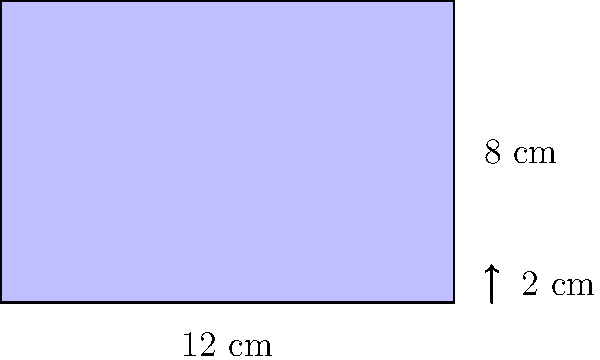You're designing a special cushion to support your baby's flat forehead during tummy time. The cushion is rectangular with dimensions 12 cm by 8 cm and a thickness of 2 cm. Calculate the total surface area of the cushion in square centimeters. To find the total surface area of the rectangular cushion, we need to calculate the area of all six faces and sum them up. Let's break it down step-by-step:

1. Front and back faces (largest faces):
   Area = length × width
   $A_1 = 12 \text{ cm} \times 8 \text{ cm} = 96 \text{ cm}^2$
   There are two of these faces, so: $2 \times 96 \text{ cm}^2 = 192 \text{ cm}^2$

2. Top and bottom faces:
   Area = length × thickness
   $A_2 = 12 \text{ cm} \times 2 \text{ cm} = 24 \text{ cm}^2$
   There are two of these faces, so: $2 \times 24 \text{ cm}^2 = 48 \text{ cm}^2$

3. Side faces:
   Area = width × thickness
   $A_3 = 8 \text{ cm} \times 2 \text{ cm} = 16 \text{ cm}^2$
   There are two of these faces, so: $2 \times 16 \text{ cm}^2 = 32 \text{ cm}^2$

4. Total surface area:
   Sum of all face areas
   $A_{\text{total}} = 192 \text{ cm}^2 + 48 \text{ cm}^2 + 32 \text{ cm}^2 = 272 \text{ cm}^2$

Therefore, the total surface area of the cushion is 272 square centimeters.
Answer: $272 \text{ cm}^2$ 